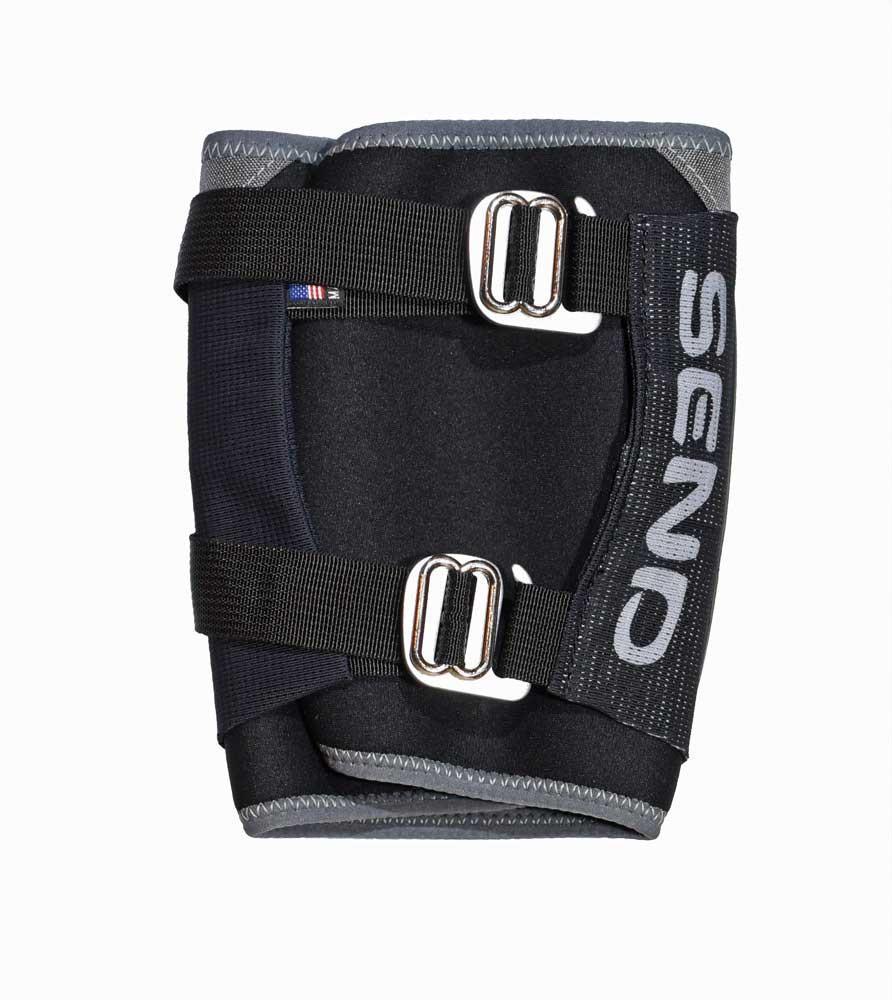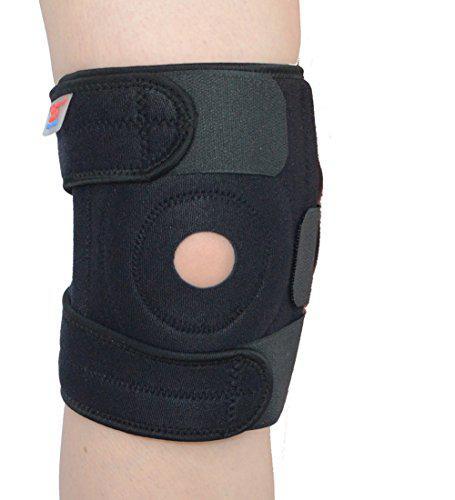The first image is the image on the left, the second image is the image on the right. Given the left and right images, does the statement "In at least one image there are four kneepads." hold true? Answer yes or no. No. The first image is the image on the left, the second image is the image on the right. Analyze the images presented: Is the assertion "All knee pads are black, and each image includes a pair of legs with at least one leg wearing a knee pad." valid? Answer yes or no. No. 